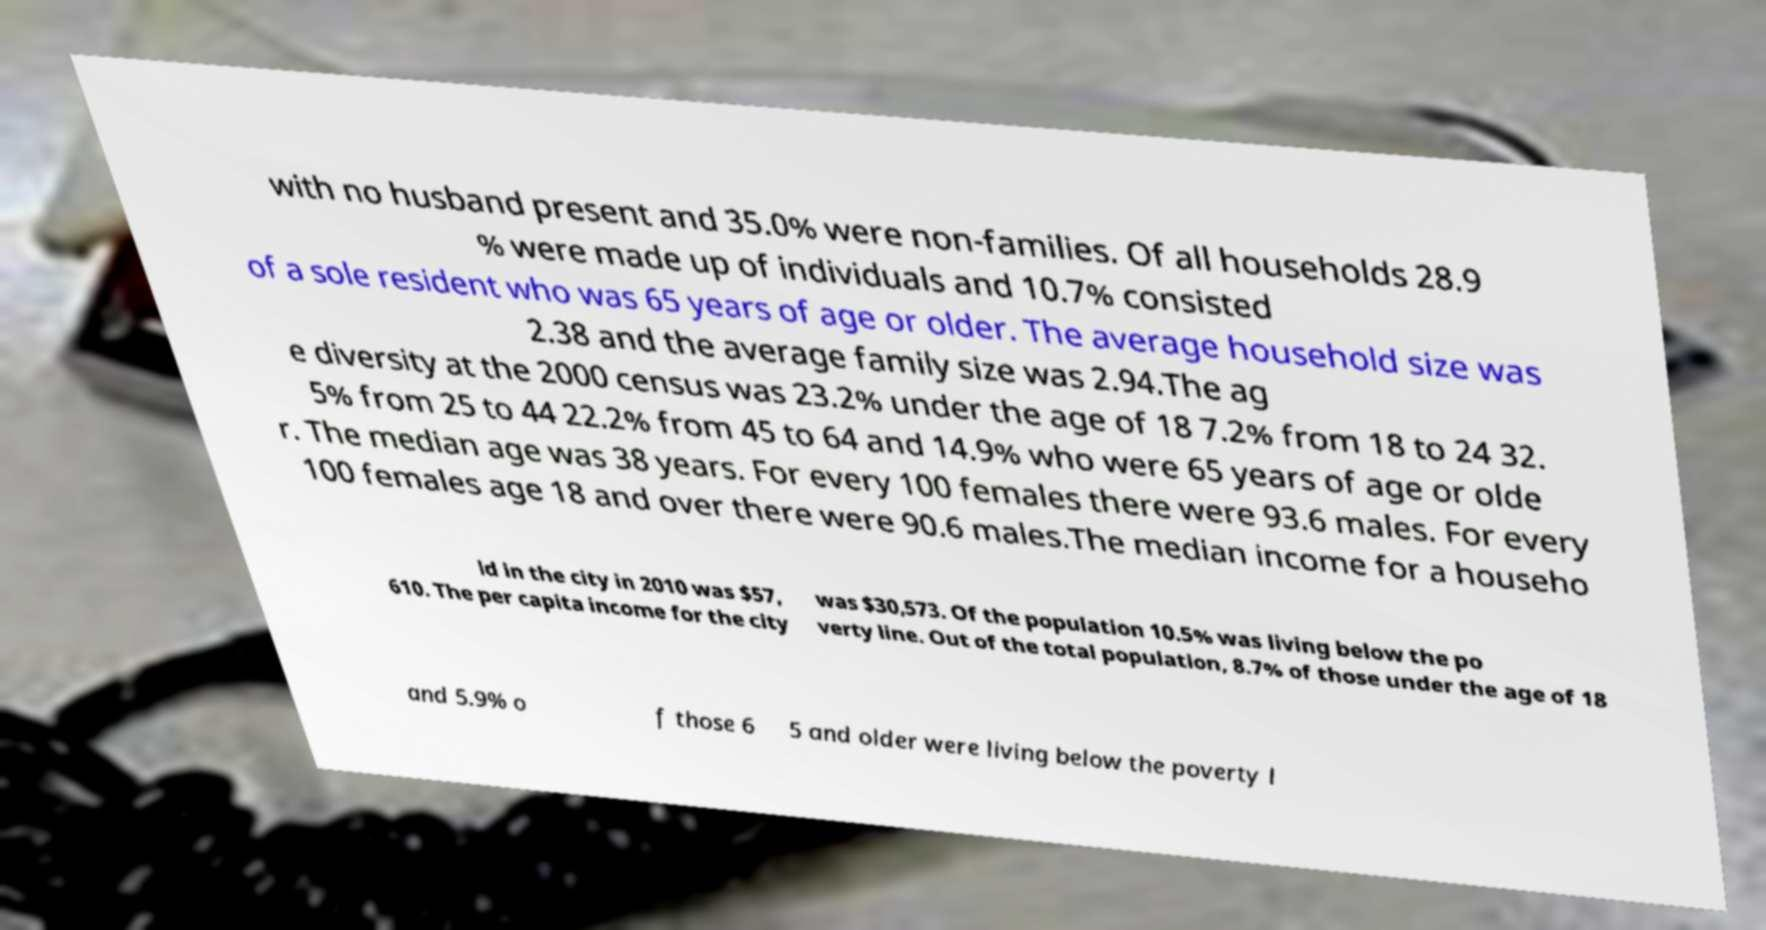Could you extract and type out the text from this image? with no husband present and 35.0% were non-families. Of all households 28.9 % were made up of individuals and 10.7% consisted of a sole resident who was 65 years of age or older. The average household size was 2.38 and the average family size was 2.94.The ag e diversity at the 2000 census was 23.2% under the age of 18 7.2% from 18 to 24 32. 5% from 25 to 44 22.2% from 45 to 64 and 14.9% who were 65 years of age or olde r. The median age was 38 years. For every 100 females there were 93.6 males. For every 100 females age 18 and over there were 90.6 males.The median income for a househo ld in the city in 2010 was $57, 610. The per capita income for the city was $30,573. Of the population 10.5% was living below the po verty line. Out of the total population, 8.7% of those under the age of 18 and 5.9% o f those 6 5 and older were living below the poverty l 